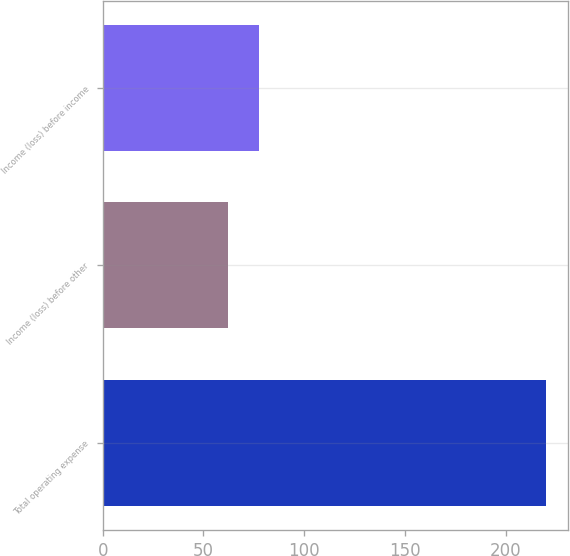<chart> <loc_0><loc_0><loc_500><loc_500><bar_chart><fcel>Total operating expense<fcel>Income (loss) before other<fcel>Income (loss) before income<nl><fcel>220<fcel>62<fcel>77.8<nl></chart> 